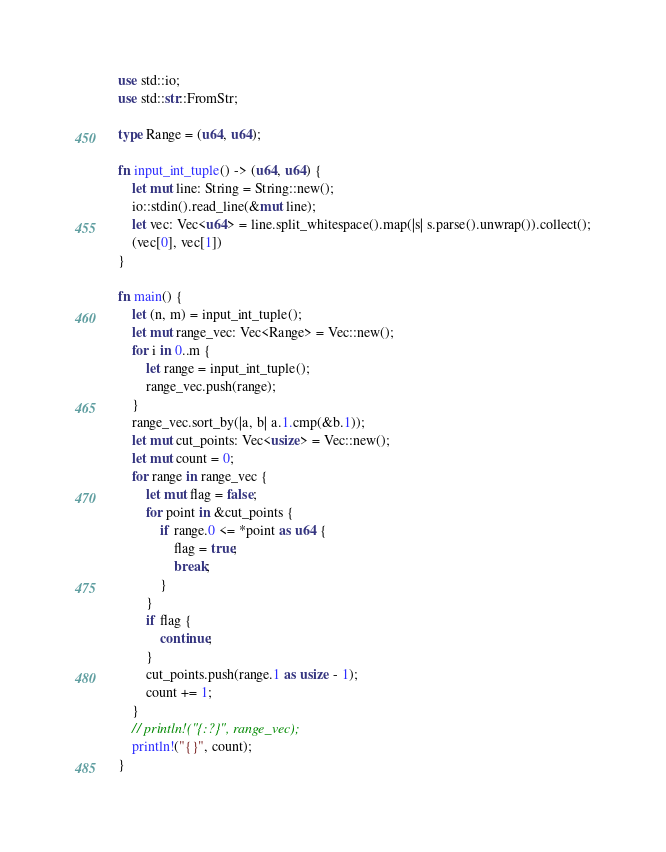<code> <loc_0><loc_0><loc_500><loc_500><_Rust_>use std::io;
use std::str::FromStr;

type Range = (u64, u64);

fn input_int_tuple() -> (u64, u64) {
    let mut line: String = String::new();
    io::stdin().read_line(&mut line);
    let vec: Vec<u64> = line.split_whitespace().map(|s| s.parse().unwrap()).collect();
    (vec[0], vec[1])
}

fn main() {
    let (n, m) = input_int_tuple();
    let mut range_vec: Vec<Range> = Vec::new();
    for i in 0..m {
        let range = input_int_tuple();
        range_vec.push(range);
    }
    range_vec.sort_by(|a, b| a.1.cmp(&b.1));
    let mut cut_points: Vec<usize> = Vec::new();
    let mut count = 0;
    for range in range_vec {
        let mut flag = false;
        for point in &cut_points {
            if range.0 <= *point as u64 {
                flag = true;
                break;
            }
        }
        if flag {
            continue;
        }
        cut_points.push(range.1 as usize - 1);
        count += 1;
    }
    // println!("{:?}", range_vec);
    println!("{}", count);
}
</code> 